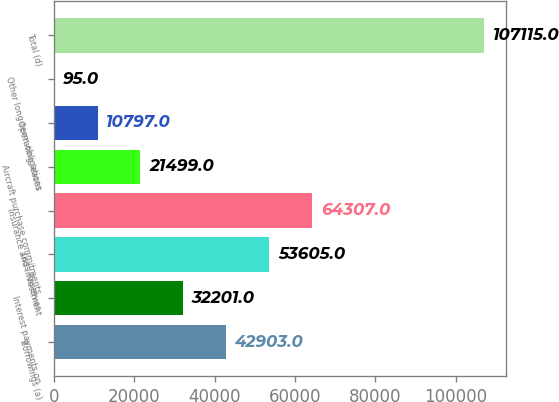Convert chart to OTSL. <chart><loc_0><loc_0><loc_500><loc_500><bar_chart><fcel>Borrowings (a)<fcel>Interest payments on<fcel>Loss Reserves<fcel>Insurance and investment<fcel>Aircraft purchase commitments<fcel>Operating leases<fcel>Other long-term obligations<fcel>Total (d)<nl><fcel>42903<fcel>32201<fcel>53605<fcel>64307<fcel>21499<fcel>10797<fcel>95<fcel>107115<nl></chart> 